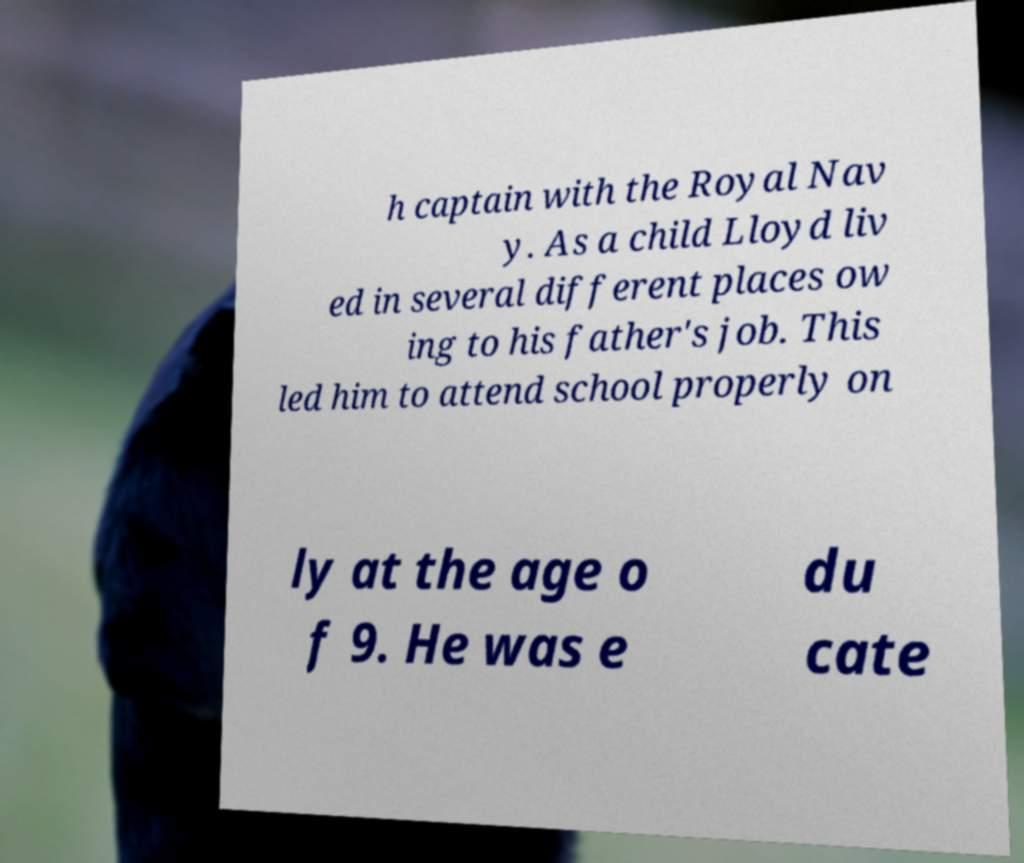I need the written content from this picture converted into text. Can you do that? h captain with the Royal Nav y. As a child Lloyd liv ed in several different places ow ing to his father's job. This led him to attend school properly on ly at the age o f 9. He was e du cate 